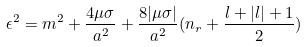Convert formula to latex. <formula><loc_0><loc_0><loc_500><loc_500>\epsilon ^ { 2 } = m ^ { 2 } + \frac { 4 \mu \sigma } { a ^ { 2 } } + \frac { 8 | \mu \sigma | } { a ^ { 2 } } ( n _ { r } + \frac { l + | l | + 1 } { 2 } )</formula> 